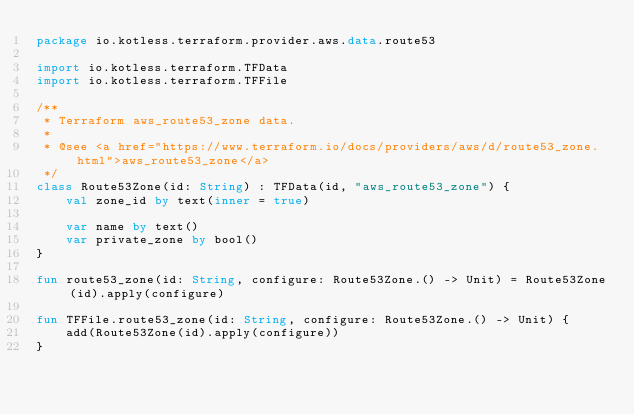Convert code to text. <code><loc_0><loc_0><loc_500><loc_500><_Kotlin_>package io.kotless.terraform.provider.aws.data.route53

import io.kotless.terraform.TFData
import io.kotless.terraform.TFFile

/**
 * Terraform aws_route53_zone data.
 *
 * @see <a href="https://www.terraform.io/docs/providers/aws/d/route53_zone.html">aws_route53_zone</a>
 */
class Route53Zone(id: String) : TFData(id, "aws_route53_zone") {
    val zone_id by text(inner = true)

    var name by text()
    var private_zone by bool()
}

fun route53_zone(id: String, configure: Route53Zone.() -> Unit) = Route53Zone(id).apply(configure)

fun TFFile.route53_zone(id: String, configure: Route53Zone.() -> Unit) {
    add(Route53Zone(id).apply(configure))
}
</code> 